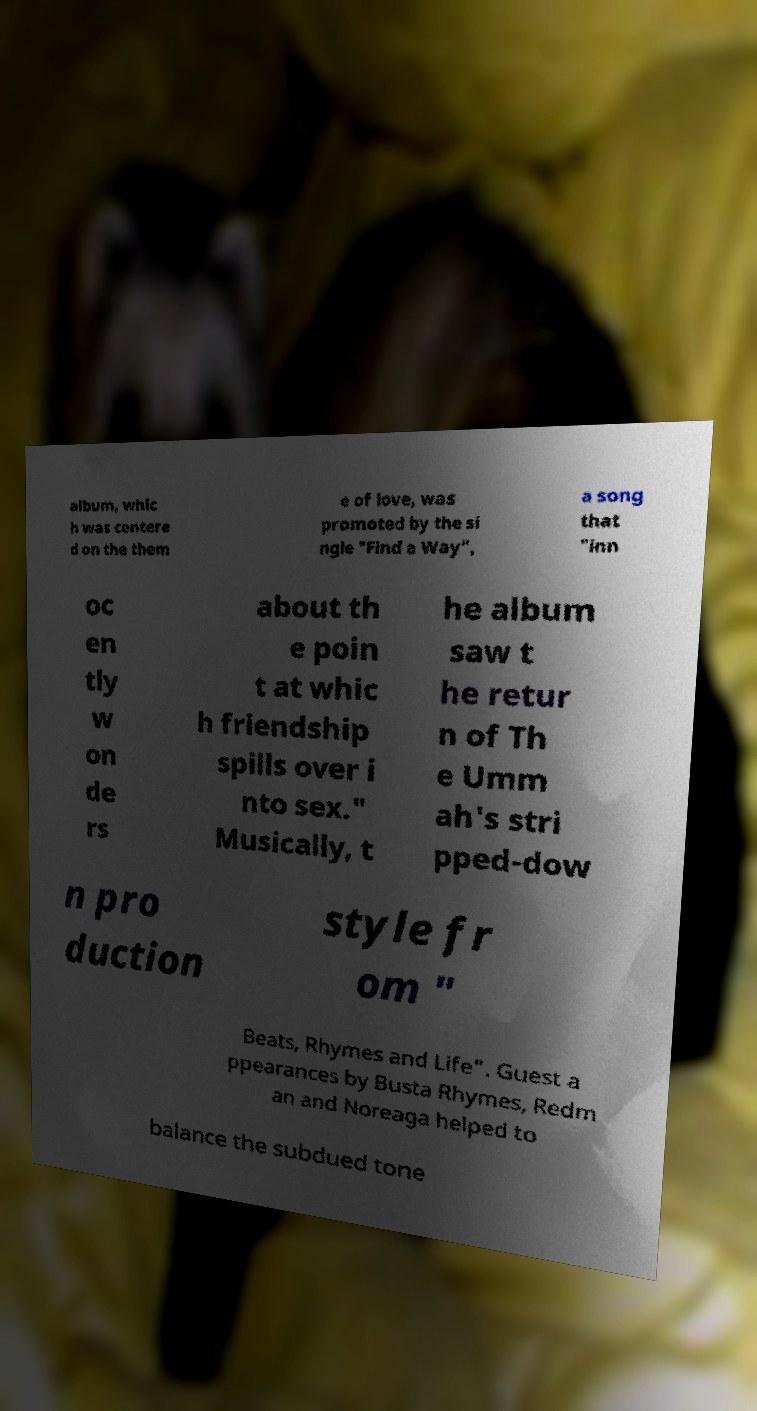For documentation purposes, I need the text within this image transcribed. Could you provide that? album, whic h was centere d on the them e of love, was promoted by the si ngle "Find a Way", a song that "inn oc en tly w on de rs about th e poin t at whic h friendship spills over i nto sex." Musically, t he album saw t he retur n of Th e Umm ah's stri pped-dow n pro duction style fr om " Beats, Rhymes and Life". Guest a ppearances by Busta Rhymes, Redm an and Noreaga helped to balance the subdued tone 